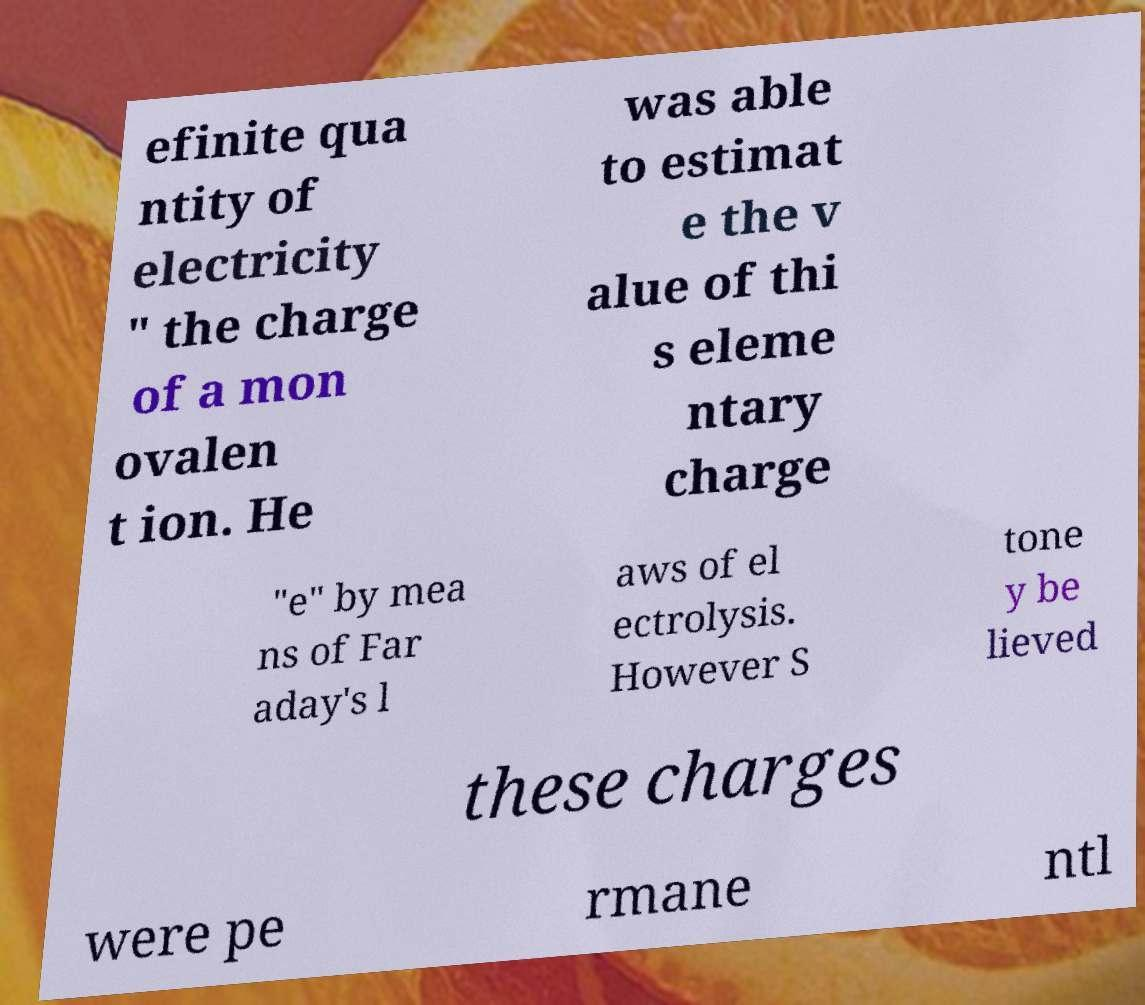Please identify and transcribe the text found in this image. efinite qua ntity of electricity " the charge of a mon ovalen t ion. He was able to estimat e the v alue of thi s eleme ntary charge "e" by mea ns of Far aday's l aws of el ectrolysis. However S tone y be lieved these charges were pe rmane ntl 